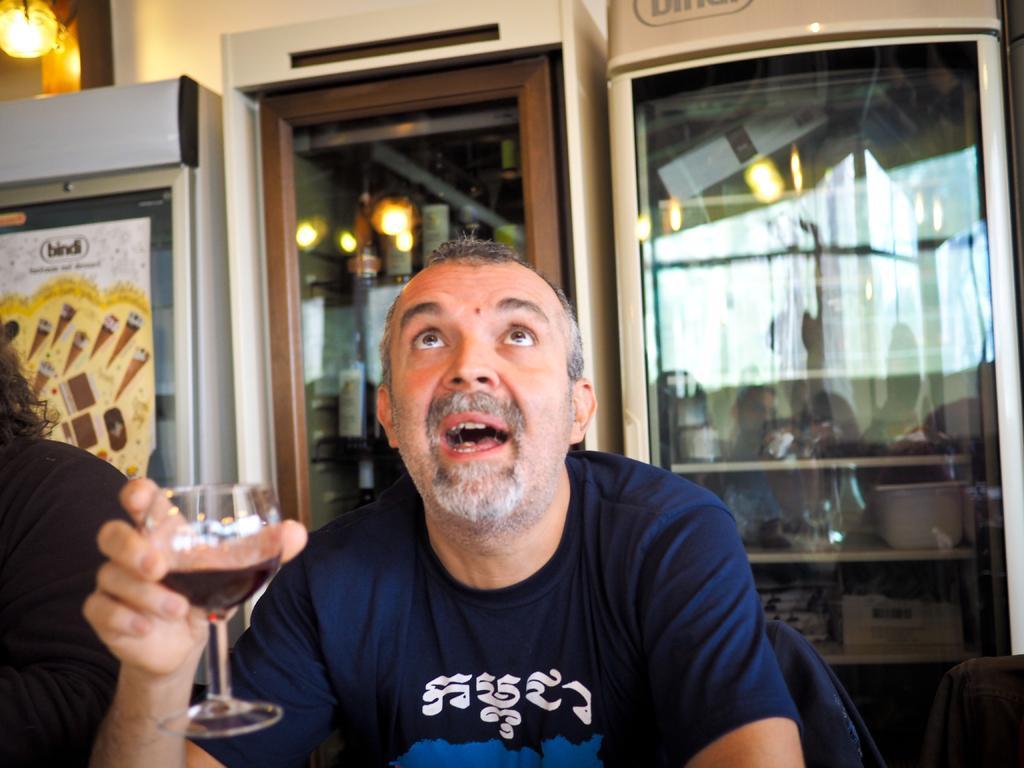Could you give a brief overview of what you see in this image? This man is sitting on a chair and holding a glass with liquid. These racks are filled with bottles, container and things. Beside this man another person is sitting on a chair. A poster on this furniture. On top there is a light. 